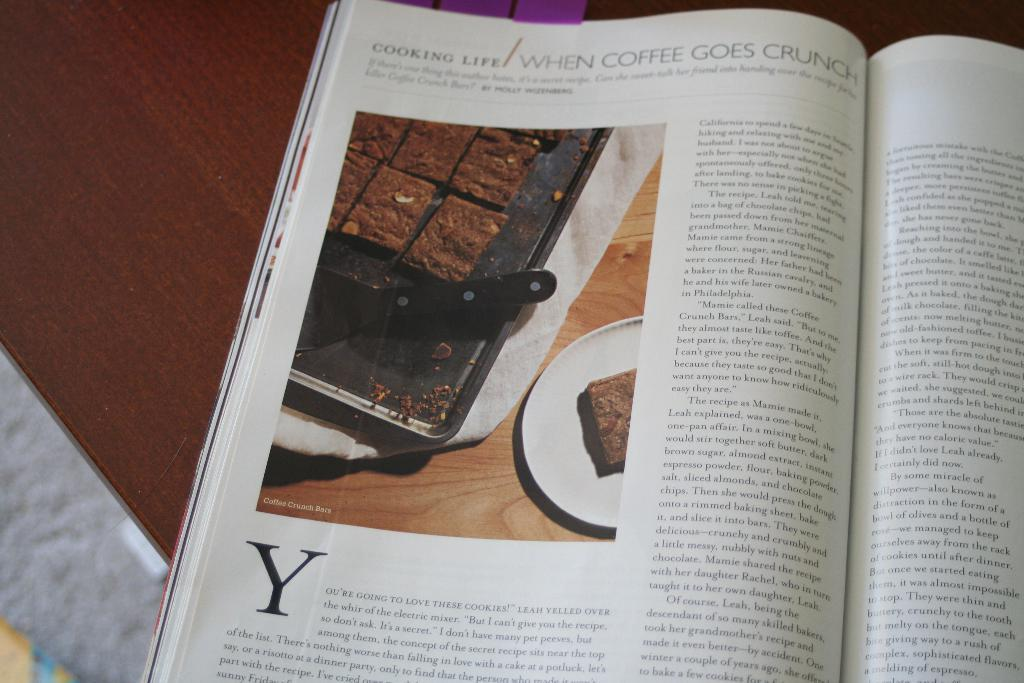Provide a one-sentence caption for the provided image. A magazine is open to a page with a picture of coffee crunch bars on it. 